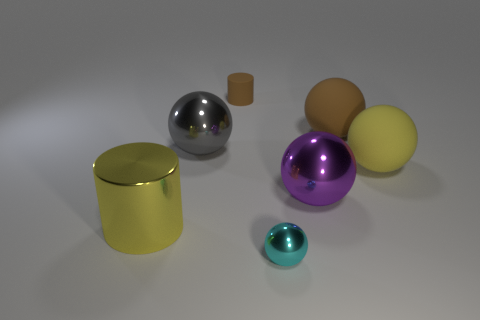Subtract all small balls. How many balls are left? 4 Subtract all brown spheres. Subtract all purple cubes. How many spheres are left? 4 Add 2 shiny balls. How many objects exist? 9 Subtract all cylinders. How many objects are left? 5 Subtract all small red blocks. Subtract all big rubber things. How many objects are left? 5 Add 1 large yellow shiny cylinders. How many large yellow shiny cylinders are left? 2 Add 3 big gray shiny spheres. How many big gray shiny spheres exist? 4 Subtract 0 gray cubes. How many objects are left? 7 